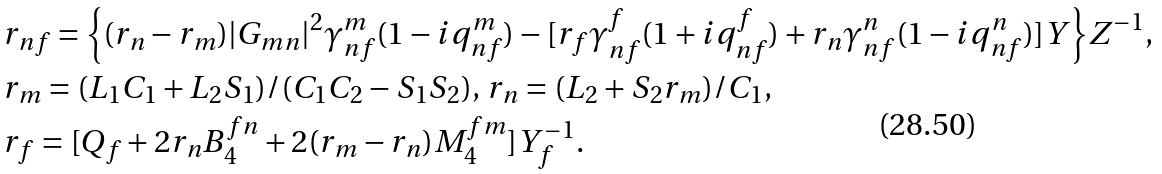Convert formula to latex. <formula><loc_0><loc_0><loc_500><loc_500>& r _ { n f } = { \left \{ ( r _ { n } - r _ { m } ) | G _ { m n } | ^ { 2 } \gamma _ { n f } ^ { m } ( 1 - i q _ { n f } ^ { m } ) - [ r _ { f } \gamma _ { n f } ^ { f } ( 1 + i q _ { n f } ^ { f } ) + r _ { n } \gamma _ { n f } ^ { n } ( 1 - i q _ { n f } ^ { n } ) ] Y \right \} } Z ^ { - 1 } , \\ & r _ { m } = ( L _ { 1 } C _ { 1 } + L _ { 2 } S _ { 1 } ) / ( C _ { 1 } C _ { 2 } - S _ { 1 } S _ { 2 } ) , \, r _ { n } = ( L _ { 2 } + S _ { 2 } r _ { m } ) / C _ { 1 } , \\ & r _ { f } = [ Q _ { f } + 2 r _ { n } B _ { 4 } ^ { f n } + 2 ( r _ { m } - r _ { n } ) M _ { 4 } ^ { f m } ] Y _ { f } ^ { - 1 } .</formula> 